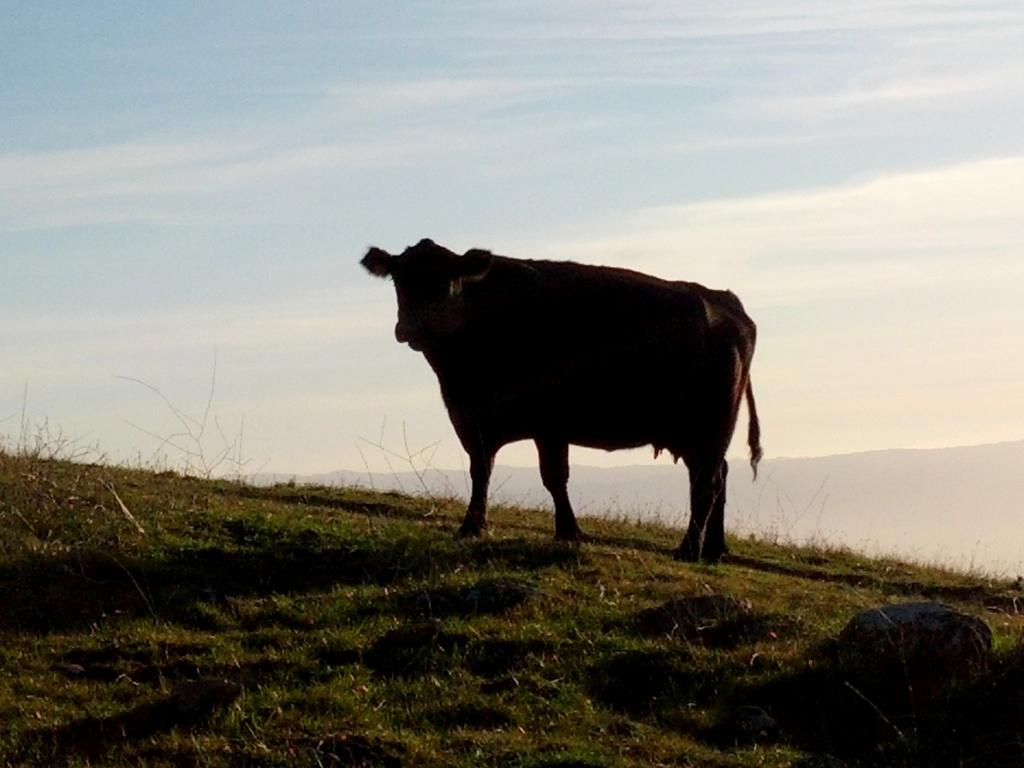What animal is present in the image? There is a cow in the image. Where is the cow located? The cow is on the grass. What can be seen on the right side of the image? There are stones on the right side of the image. What is visible in the background of the image? Hills and the sky are visible in the background of the image. What is the condition of the sky in the image? Clouds are present in the sky. Can you see the ocean in the image? No, the ocean is not present in the image. The image features a cow on grass, stones, hills, and a sky with clouds. 